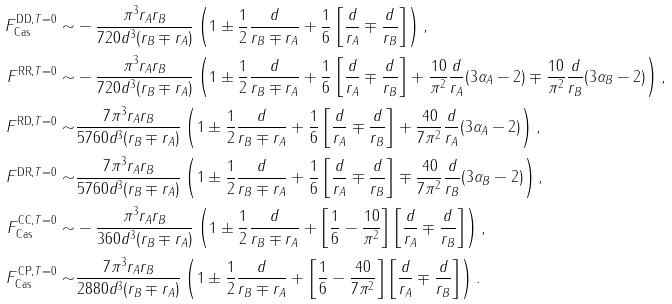Convert formula to latex. <formula><loc_0><loc_0><loc_500><loc_500>F ^ { \text {DD} , T = 0 } _ { \text {Cas} } \sim & - \frac { \pi ^ { 3 } r _ { A } r _ { B } } { 7 2 0 d ^ { 3 } ( r _ { B } \mp r _ { A } ) } \left ( 1 \pm \frac { 1 } { 2 } \frac { d } { r _ { B } \mp r _ { A } } + \frac { 1 } { 6 } \left [ \frac { d } { r _ { A } } \mp \frac { d } { r _ { B } } \right ] \right ) , \\ F ^ { \text {RR} , T = 0 } \sim & - \frac { \pi ^ { 3 } r _ { A } r _ { B } } { 7 2 0 d ^ { 3 } ( r _ { B } \mp r _ { A } ) } \left ( 1 \pm \frac { 1 } { 2 } \frac { d } { r _ { B } \mp r _ { A } } + \frac { 1 } { 6 } \left [ \frac { d } { r _ { A } } \mp \frac { d } { r _ { B } } \right ] + \frac { 1 0 } { \pi ^ { 2 } } \frac { d } { r _ { A } } ( 3 \alpha _ { A } - 2 ) \mp \frac { 1 0 } { \pi ^ { 2 } } \frac { d } { r _ { B } } ( 3 \alpha _ { B } - 2 ) \right ) , \\ F ^ { \text {RD} , T = 0 } \sim & \frac { 7 \pi ^ { 3 } r _ { A } r _ { B } } { 5 7 6 0 d ^ { 3 } ( r _ { B } \mp r _ { A } ) } \left ( 1 \pm \frac { 1 } { 2 } \frac { d } { r _ { B } \mp r _ { A } } + \frac { 1 } { 6 } \left [ \frac { d } { r _ { A } } \mp \frac { d } { r _ { B } } \right ] + \frac { 4 0 } { 7 \pi ^ { 2 } } \frac { d } { r _ { A } } ( 3 \alpha _ { A } - 2 ) \right ) , \\ F ^ { \text {DR} , T = 0 } \sim & \frac { 7 \pi ^ { 3 } r _ { A } r _ { B } } { 5 7 6 0 d ^ { 3 } ( r _ { B } \mp r _ { A } ) } \left ( 1 \pm \frac { 1 } { 2 } \frac { d } { r _ { B } \mp r _ { A } } + \frac { 1 } { 6 } \left [ \frac { d } { r _ { A } } \mp \frac { d } { r _ { B } } \right ] \mp \frac { 4 0 } { 7 \pi ^ { 2 } } \frac { d } { r _ { B } } ( 3 \alpha _ { B } - 2 ) \right ) , \\ F _ { \text {Cas} } ^ { \text {CC} , T = 0 } \sim & - \frac { \pi ^ { 3 } r _ { A } r _ { B } } { 3 6 0 d ^ { 3 } ( r _ { B } \mp r _ { A } ) } \left ( 1 \pm \frac { 1 } { 2 } \frac { d } { r _ { B } \mp r _ { A } } + \left [ \frac { 1 } { 6 } - \frac { 1 0 } { \pi ^ { 2 } } \right ] \left [ \frac { d } { r _ { A } } \mp \frac { d } { r _ { B } } \right ] \right ) , \\ F _ { \text {Cas} } ^ { \text {CP} , T = 0 } \sim & \frac { 7 \pi ^ { 3 } r _ { A } r _ { B } } { 2 8 8 0 d ^ { 3 } ( r _ { B } \mp r _ { A } ) } \left ( 1 \pm \frac { 1 } { 2 } \frac { d } { r _ { B } \mp r _ { A } } + \left [ \frac { 1 } { 6 } - \frac { 4 0 } { 7 \pi ^ { 2 } } \right ] \left [ \frac { d } { r _ { A } } \mp \frac { d } { r _ { B } } \right ] \right ) .</formula> 